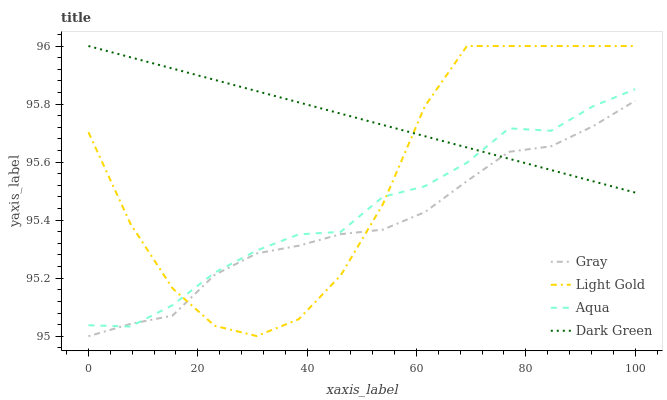Does Gray have the minimum area under the curve?
Answer yes or no. Yes. Does Dark Green have the maximum area under the curve?
Answer yes or no. Yes. Does Light Gold have the minimum area under the curve?
Answer yes or no. No. Does Light Gold have the maximum area under the curve?
Answer yes or no. No. Is Dark Green the smoothest?
Answer yes or no. Yes. Is Light Gold the roughest?
Answer yes or no. Yes. Is Gray the smoothest?
Answer yes or no. No. Is Gray the roughest?
Answer yes or no. No. Does Gray have the lowest value?
Answer yes or no. Yes. Does Light Gold have the lowest value?
Answer yes or no. No. Does Dark Green have the highest value?
Answer yes or no. Yes. Does Gray have the highest value?
Answer yes or no. No. Does Aqua intersect Gray?
Answer yes or no. Yes. Is Aqua less than Gray?
Answer yes or no. No. Is Aqua greater than Gray?
Answer yes or no. No. 